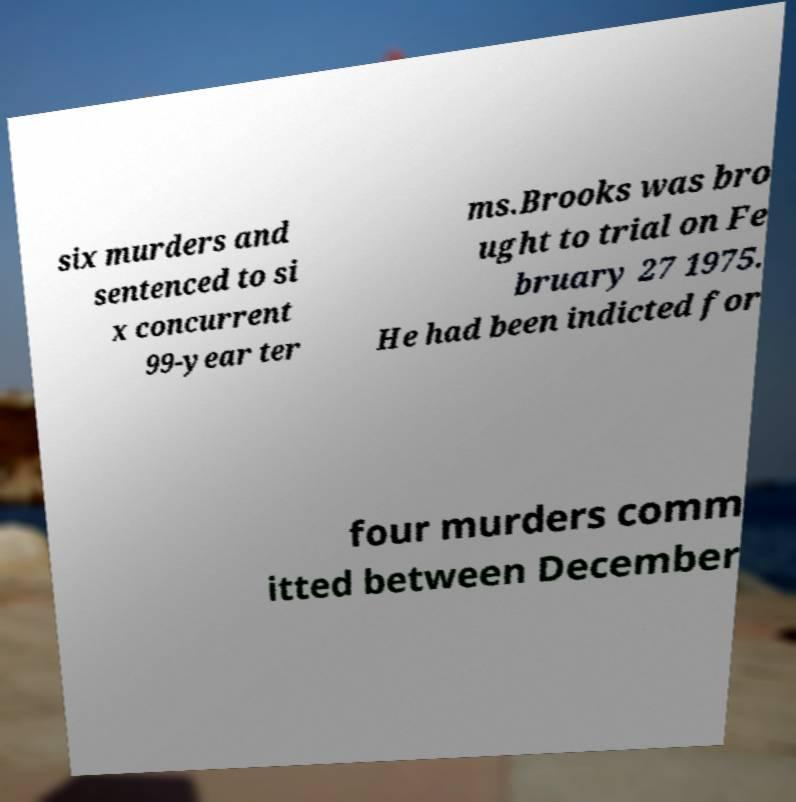Could you assist in decoding the text presented in this image and type it out clearly? six murders and sentenced to si x concurrent 99-year ter ms.Brooks was bro ught to trial on Fe bruary 27 1975. He had been indicted for four murders comm itted between December 